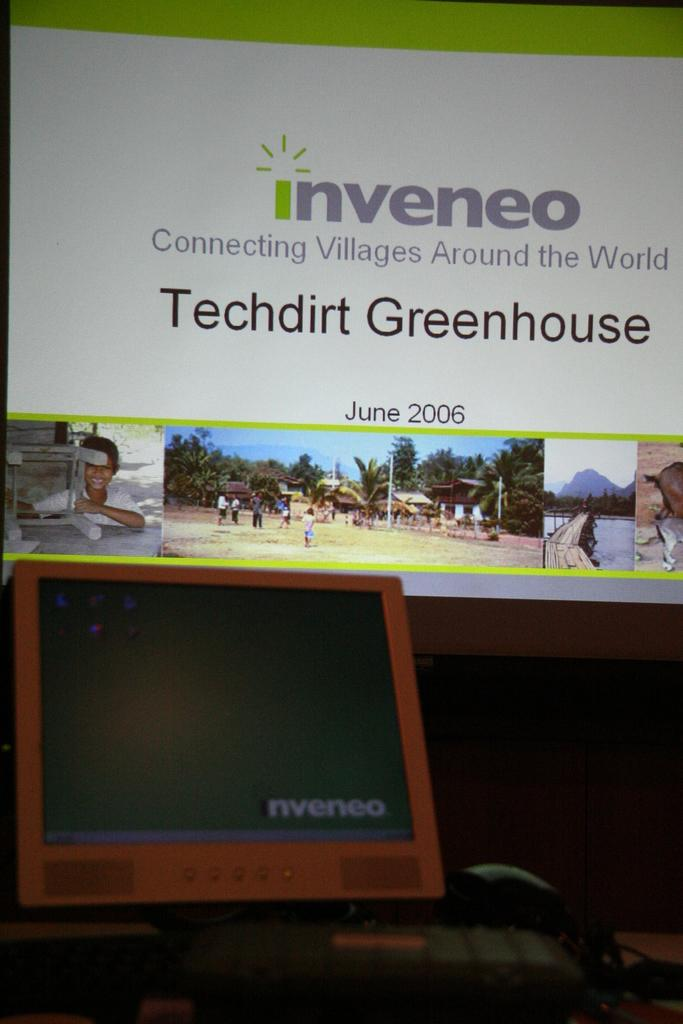<image>
Offer a succinct explanation of the picture presented. A sign from the company inveneo talking about a greenhouse. 